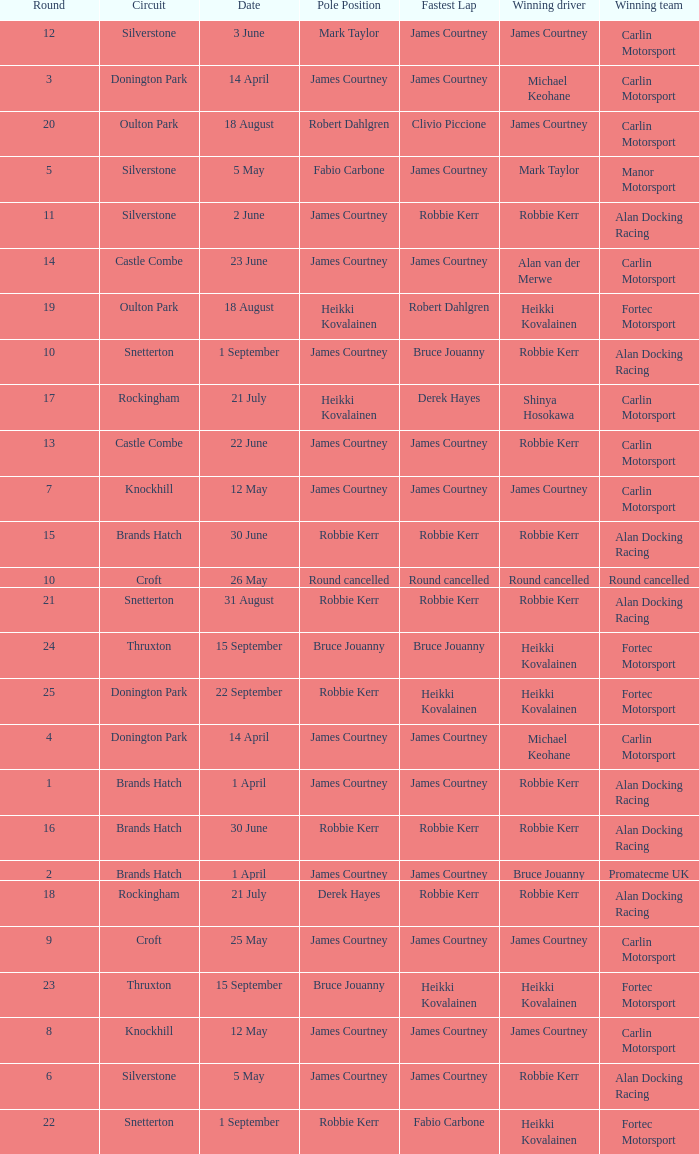How many rounds have Fabio Carbone for fastest lap? 1.0. 